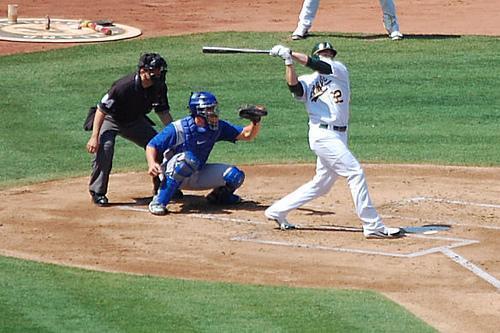How many hitter's are there?
Give a very brief answer. 1. How many legs can you see in the photo?
Give a very brief answer. 8. How many people are in the photo?
Give a very brief answer. 3. How many red fish kites are there?
Give a very brief answer. 0. 